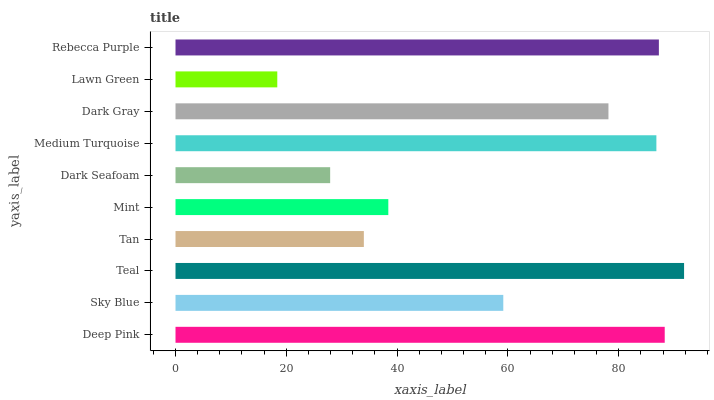Is Lawn Green the minimum?
Answer yes or no. Yes. Is Teal the maximum?
Answer yes or no. Yes. Is Sky Blue the minimum?
Answer yes or no. No. Is Sky Blue the maximum?
Answer yes or no. No. Is Deep Pink greater than Sky Blue?
Answer yes or no. Yes. Is Sky Blue less than Deep Pink?
Answer yes or no. Yes. Is Sky Blue greater than Deep Pink?
Answer yes or no. No. Is Deep Pink less than Sky Blue?
Answer yes or no. No. Is Dark Gray the high median?
Answer yes or no. Yes. Is Sky Blue the low median?
Answer yes or no. Yes. Is Dark Seafoam the high median?
Answer yes or no. No. Is Dark Gray the low median?
Answer yes or no. No. 